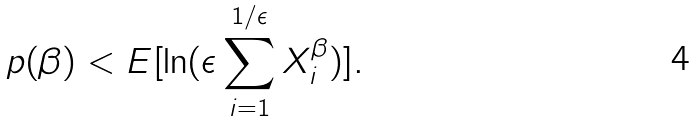Convert formula to latex. <formula><loc_0><loc_0><loc_500><loc_500>p ( \beta ) < E [ \ln ( \epsilon \sum _ { i = 1 } ^ { 1 / \epsilon } X _ { i } ^ { \beta } ) ] .</formula> 